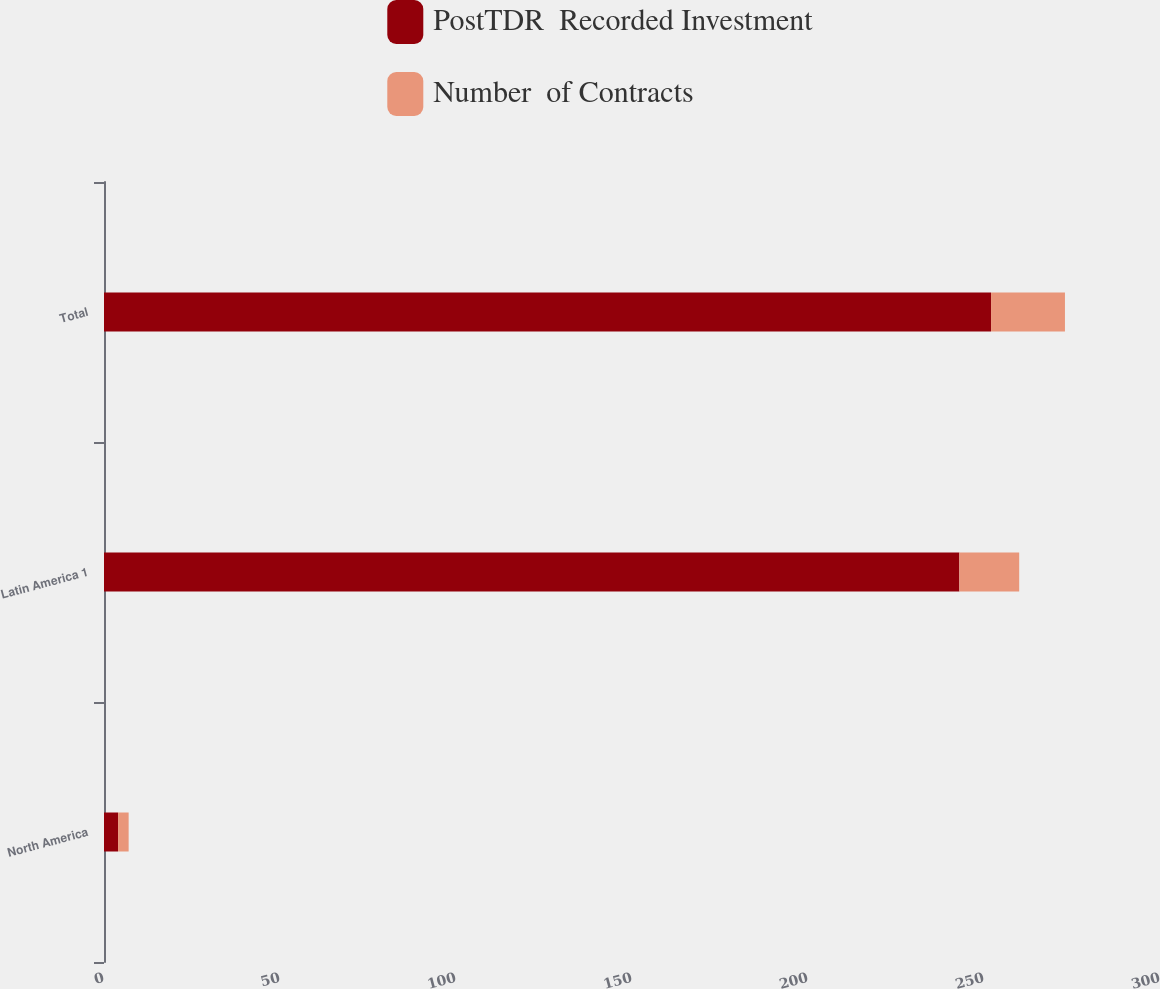Convert chart to OTSL. <chart><loc_0><loc_0><loc_500><loc_500><stacked_bar_chart><ecel><fcel>North America<fcel>Latin America 1<fcel>Total<nl><fcel>PostTDR  Recorded Investment<fcel>4<fcel>243<fcel>252<nl><fcel>Number  of Contracts<fcel>3<fcel>17<fcel>21<nl></chart> 